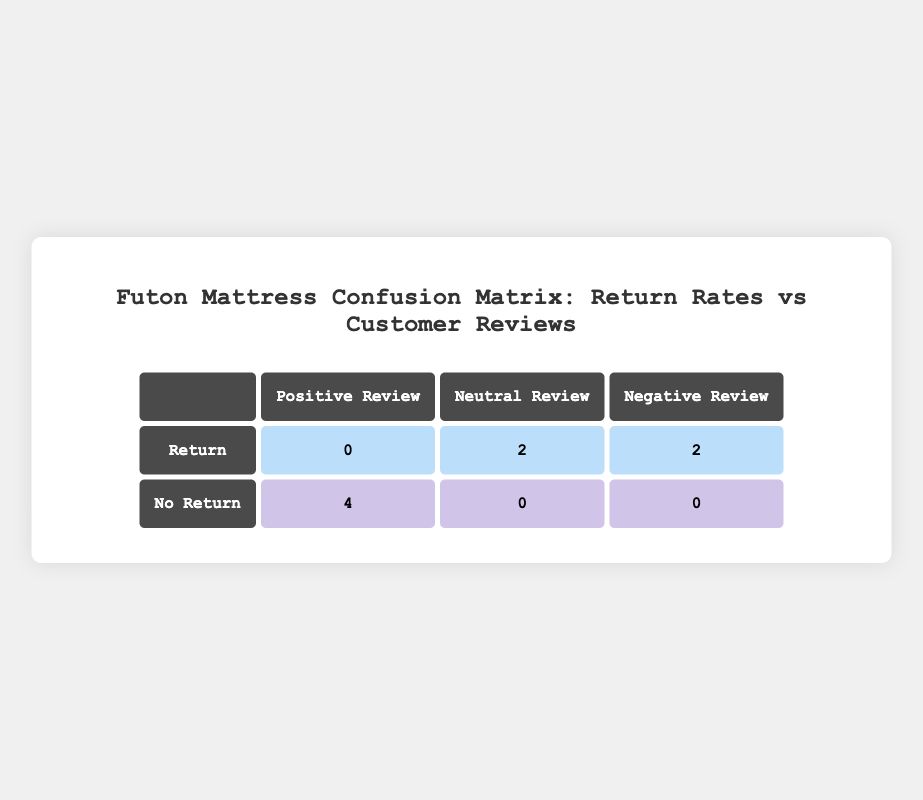What is the total number of mattresses with positive reviews that had no returns? By looking at the "Positive Review" column under the "No Return" row, there are 4 mattresses listed.
Answer: 4 How many mattresses received neutral reviews and were returned? There are 2 mattresses mentioned under the "Neutral Review" row in the "Return" column.
Answer: 2 Is there any mattress that received a positive review and was returned? The table shows that under the "Return" column, there are 0 mattresses listed for "Positive Review."
Answer: No What is the total number of mattresses that received negative reviews? There are 2 mattresses listed in the "Negative Review" column under both "Return" and "No Return." When combined, this gives a total of 2 + 0 = 2.
Answer: 2 What is the ratio of returned mattresses to those that received no return? The total number of returned mattresses is 4 (2 neutral + 2 negative) and the total number with no returns is 4 (all positive). The ratio is 4:4, which simplifies to 1:1.
Answer: 1:1 How many mattresses were returned vs. how many had no returns overall? The table shows 4 mattresses were returned (2 neutral, 2 negative) and 4 mattresses had no returns (all positive). Therefore, both categories have an equal count.
Answer: 4 returned, 4 no returns Which customer review type had the highest return rate? Both "Neutral" and "Negative" reviews had returns (2 each) whereas "Positive" reviews had 0 returns. Thus, "Neutral" and "Negative" reviews had the highest return rate together.
Answer: Neutral and Negative What percentage of total mattresses had no returns? There are a total of 8 mattresses. The number with no returns is 4. Therefore, the percentage is (4/8)*100 = 50%.
Answer: 50% Which mattress review category had the least amount of returns? Regarding the "Return" column, "Positive Review" had 0 returns. Hence, "Positive" review category had the least amount of returns.
Answer: Positive Review 